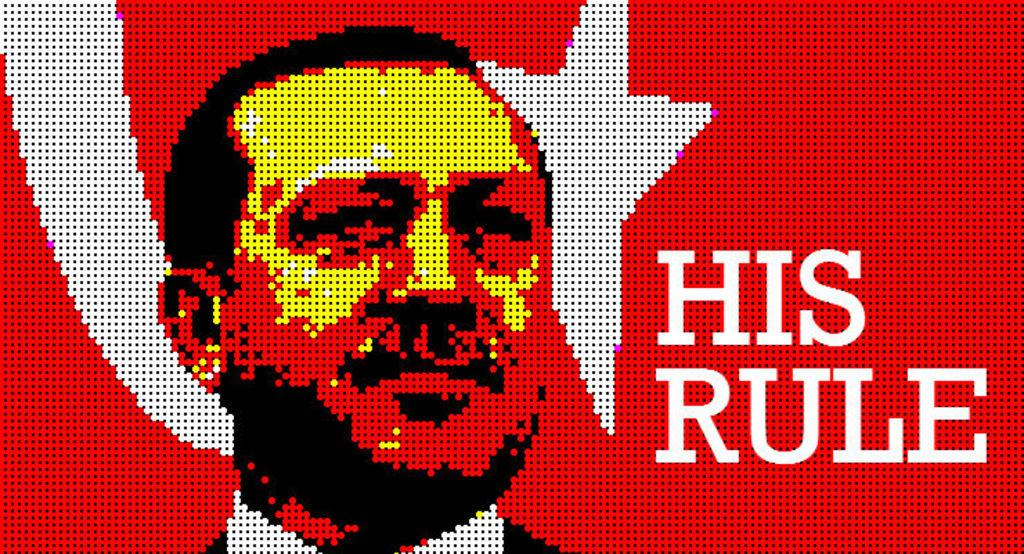What is the main subject of the image? There is a depiction of a person in the center of the image. Can you describe any additional elements in the image? There is some text in the image. What type of nerve can be seen in the image? There is no nerve present in the image; it features a depiction of a person and some text. What color is the skirt worn by the person in the image? There is no skirt visible in the image, as it only depicts a person and some text. 